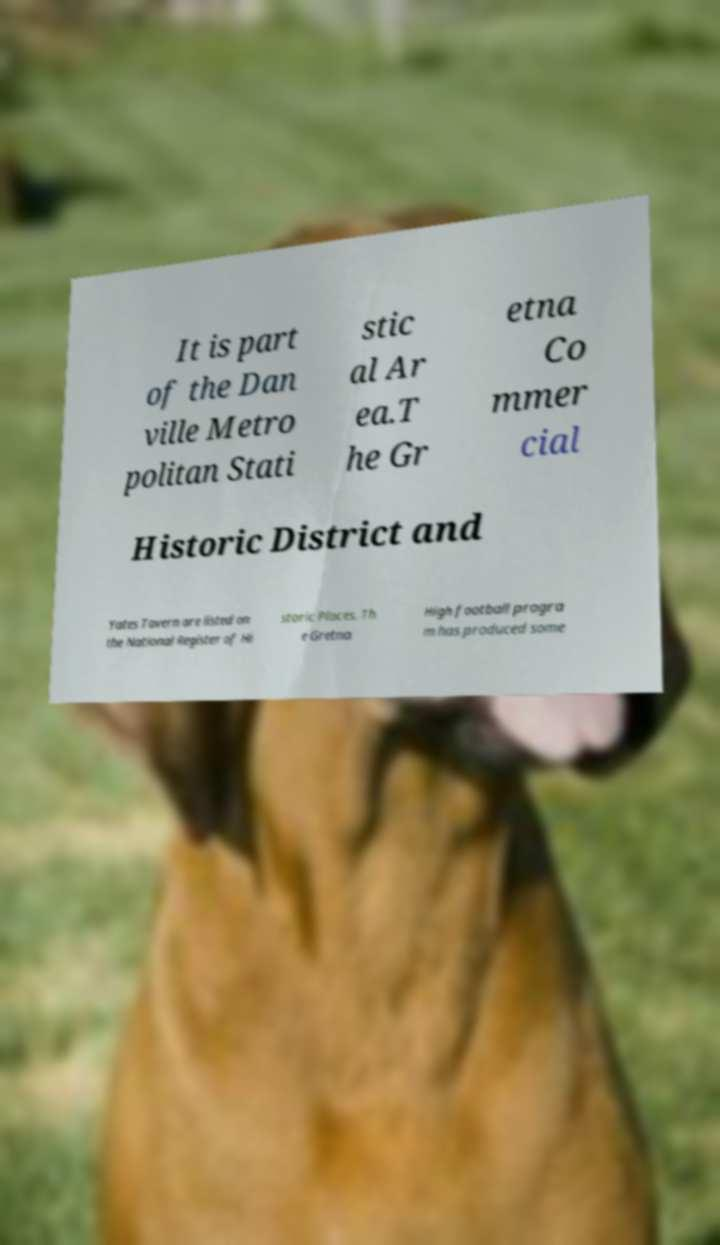Please identify and transcribe the text found in this image. It is part of the Dan ville Metro politan Stati stic al Ar ea.T he Gr etna Co mmer cial Historic District and Yates Tavern are listed on the National Register of Hi storic Places. Th e Gretna High football progra m has produced some 